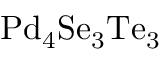Convert formula to latex. <formula><loc_0><loc_0><loc_500><loc_500>P d _ { 4 } S e _ { 3 } T e _ { 3 }</formula> 